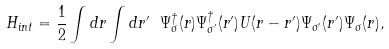Convert formula to latex. <formula><loc_0><loc_0><loc_500><loc_500>H _ { i n t } = \frac { 1 } { 2 } \int d r \int d r ^ { \prime } \ \Psi _ { \sigma } ^ { \dagger } ( r ) \Psi _ { \sigma ^ { \prime } } ^ { \dagger } ( r ^ { \prime } ) U ( r - r ^ { \prime } ) \Psi _ { \sigma ^ { \prime } } ( r ^ { \prime } ) \Psi _ { \sigma } ( r ) ,</formula> 